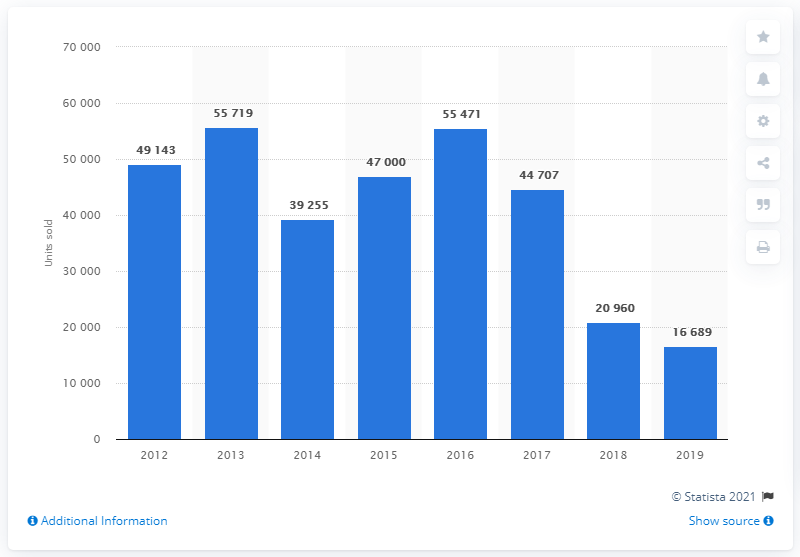List a handful of essential elements in this visual. In 2019, Opel sold a total of 16,689 cars in Turkey. In 2013, Opel sold a total of 55,471 cars in Turkey. 